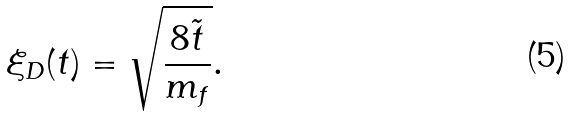Convert formula to latex. <formula><loc_0><loc_0><loc_500><loc_500>\xi _ { D } ( t ) = \sqrt { \frac { 8 \tilde { t } } { m _ { f } } } .</formula> 